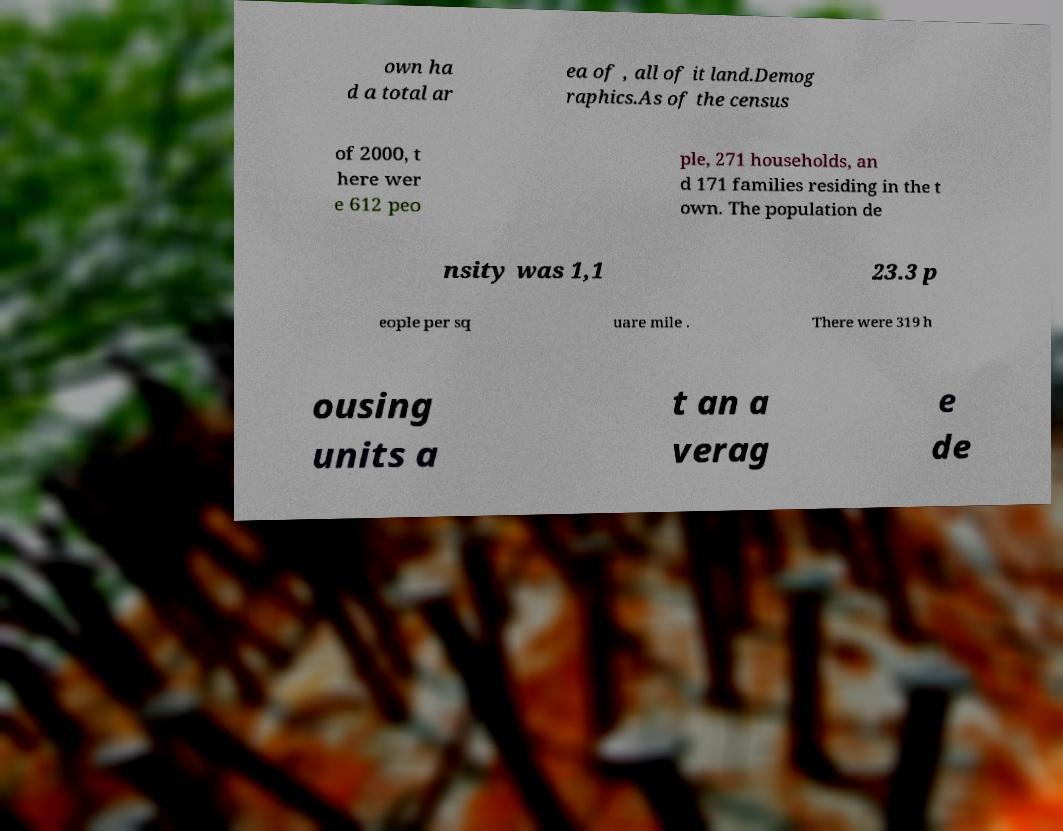Can you accurately transcribe the text from the provided image for me? own ha d a total ar ea of , all of it land.Demog raphics.As of the census of 2000, t here wer e 612 peo ple, 271 households, an d 171 families residing in the t own. The population de nsity was 1,1 23.3 p eople per sq uare mile . There were 319 h ousing units a t an a verag e de 